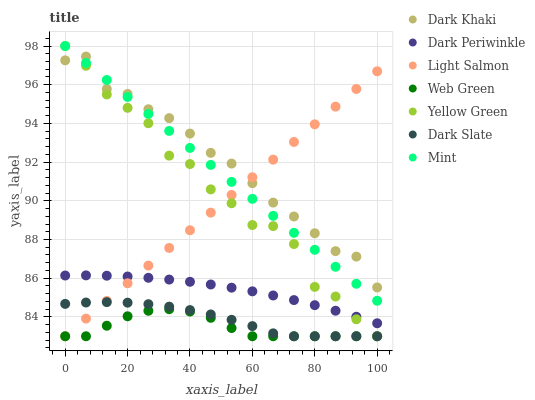Does Web Green have the minimum area under the curve?
Answer yes or no. Yes. Does Dark Khaki have the maximum area under the curve?
Answer yes or no. Yes. Does Yellow Green have the minimum area under the curve?
Answer yes or no. No. Does Yellow Green have the maximum area under the curve?
Answer yes or no. No. Is Light Salmon the smoothest?
Answer yes or no. Yes. Is Yellow Green the roughest?
Answer yes or no. Yes. Is Web Green the smoothest?
Answer yes or no. No. Is Web Green the roughest?
Answer yes or no. No. Does Light Salmon have the lowest value?
Answer yes or no. Yes. Does Dark Khaki have the lowest value?
Answer yes or no. No. Does Mint have the highest value?
Answer yes or no. Yes. Does Web Green have the highest value?
Answer yes or no. No. Is Dark Slate less than Dark Periwinkle?
Answer yes or no. Yes. Is Dark Periwinkle greater than Web Green?
Answer yes or no. Yes. Does Dark Slate intersect Light Salmon?
Answer yes or no. Yes. Is Dark Slate less than Light Salmon?
Answer yes or no. No. Is Dark Slate greater than Light Salmon?
Answer yes or no. No. Does Dark Slate intersect Dark Periwinkle?
Answer yes or no. No. 